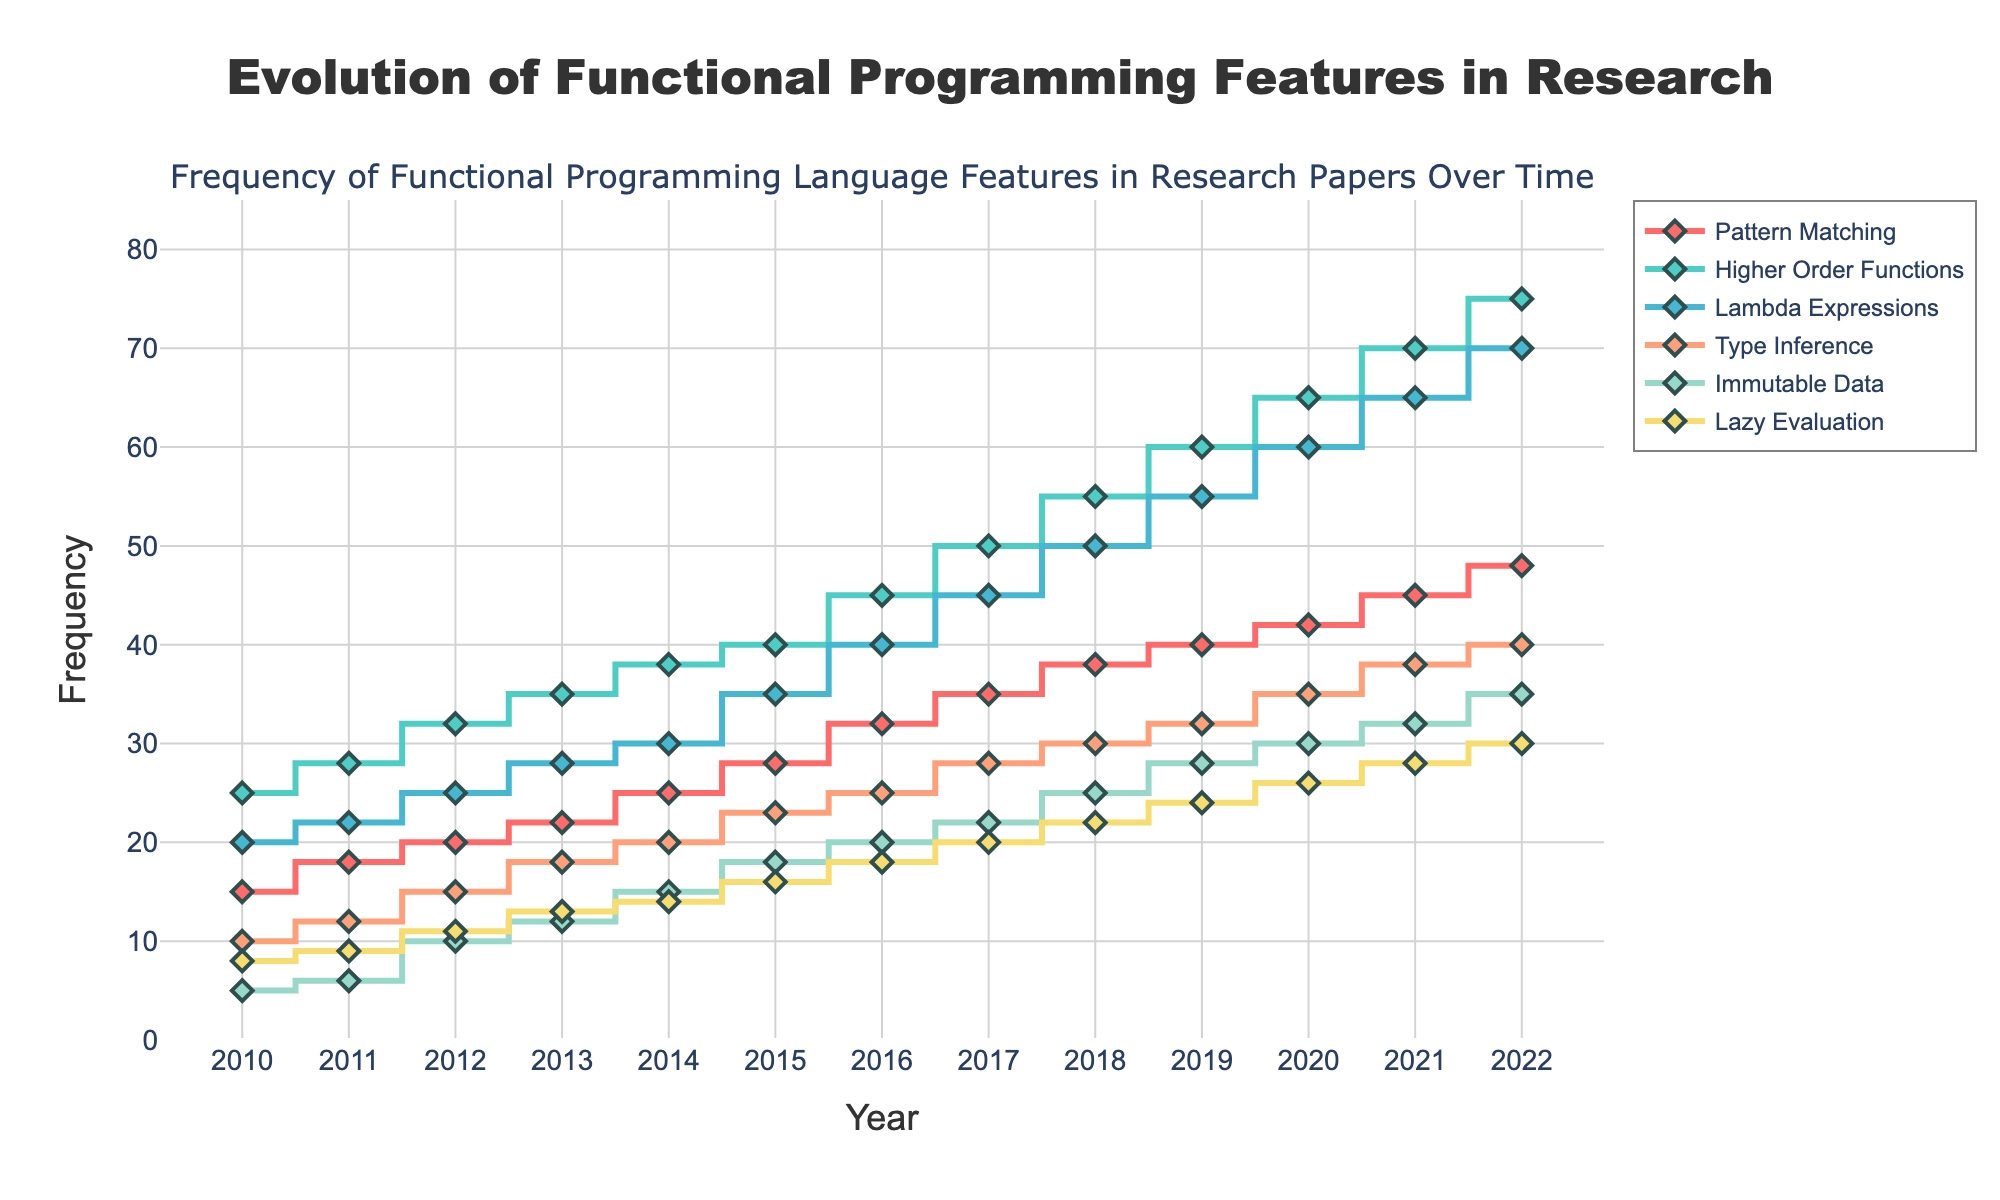What is the highest frequency value recorded for the "Lambda Expressions" feature? To find the highest frequency value for "Lambda Expressions", look for the peak of its line on the graph. The highest point occurs in 2022 with a value of 70.
Answer: 70 In which year did the "Pattern Matching" feature first surpass a frequency of 40? To determine when "Pattern Matching" first exceeded 40, trace the data line for "Pattern Matching". It first passes 40 in the year 2019 with a value of 40 exactly.
Answer: 2019 Compare the frequency of "Immutable Data" in 2015 and 2020. Which year has the higher frequency, and by how much? Locate the values for "Immutable Data" in 2015 (18) and 2020 (30). Subtract the 2015 value from the 2020 value to find the difference.
Answer: 2020, higher by 12 How has the frequency of "Lazy Evaluation" changed from 2010 to 2022? Look at the "Lazy Evaluation" data points in 2010 (8) and 2022 (30). Subtract the 2010 value from the 2022 value to see the change over time.
Answer: Increased by 22 Which feature shows the most significant increase in frequency between 2010 and 2022? Calculate the difference between the values in 2010 and 2022 for all features. "Higher Order Functions" increased from 25 to 75, which is the largest increase of 50.
Answer: Higher Order Functions When did "Type Inference" first reach a frequency of 25? Trace the line for "Type Inference" until it hits 25. It first reaches 25 in 2016.
Answer: 2016 What is the relative ranking of "Pattern Matching" compared to other features in 2022? List the 2022 values for each feature and order them. "Pattern Matching" has a frequency of 48, making it the third most frequent after "Higher Order Functions" and "Lambda Expressions".
Answer: 3rd Calculate the average frequency of "Higher Order Functions" from 2010 to 2022. Sum the values of "Higher Order Functions" from 2010 (25) to 2022 (75) and divide by the number of years (13). (25+28+32+35+38+40+45+50+55+60+65+70+75)/13 = 47.69
Answer: 47.69 Which year saw the smallest frequency difference between "Pattern Matching" and "Lambda Expressions"? Compute the absolute difference between "Pattern Matching" and "Lambda Expressions" for each year from 2010 to 2022, then find the smallest. The smallest difference occurs in 2014 with a difference of 5 (25-20).
Answer: 2014 